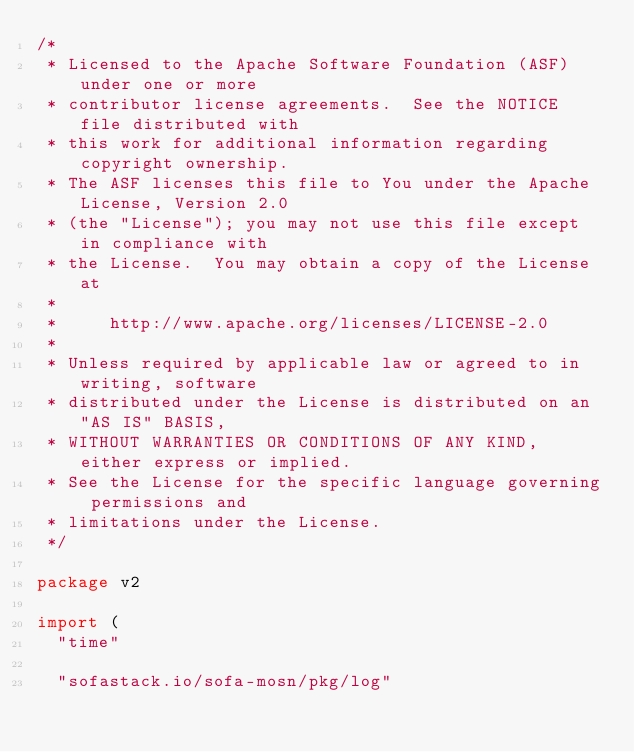<code> <loc_0><loc_0><loc_500><loc_500><_Go_>/*
 * Licensed to the Apache Software Foundation (ASF) under one or more
 * contributor license agreements.  See the NOTICE file distributed with
 * this work for additional information regarding copyright ownership.
 * The ASF licenses this file to You under the Apache License, Version 2.0
 * (the "License"); you may not use this file except in compliance with
 * the License.  You may obtain a copy of the License at
 *
 *     http://www.apache.org/licenses/LICENSE-2.0
 *
 * Unless required by applicable law or agreed to in writing, software
 * distributed under the License is distributed on an "AS IS" BASIS,
 * WITHOUT WARRANTIES OR CONDITIONS OF ANY KIND, either express or implied.
 * See the License for the specific language governing permissions and
 * limitations under the License.
 */

package v2

import (
	"time"

	"sofastack.io/sofa-mosn/pkg/log"</code> 